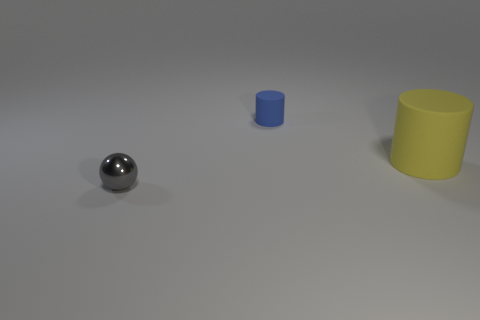Are there any blue matte cylinders of the same size as the metal ball?
Give a very brief answer. Yes. How many things are either gray spheres or big matte things?
Offer a very short reply. 2. There is a rubber thing that is in front of the tiny matte thing; does it have the same size as the object that is on the left side of the tiny blue object?
Make the answer very short. No. Are there any large blue metal objects that have the same shape as the yellow matte object?
Ensure brevity in your answer.  No. Are there fewer matte cylinders in front of the blue cylinder than tiny shiny balls?
Give a very brief answer. No. Is the shiny object the same shape as the small blue thing?
Your response must be concise. No. There is a matte object that is on the right side of the blue matte thing; what size is it?
Give a very brief answer. Large. What is the size of the yellow cylinder that is made of the same material as the blue cylinder?
Keep it short and to the point. Large. Are there fewer big blue shiny spheres than small gray things?
Provide a short and direct response. Yes. There is another object that is the same size as the blue rubber thing; what material is it?
Your answer should be compact. Metal. 